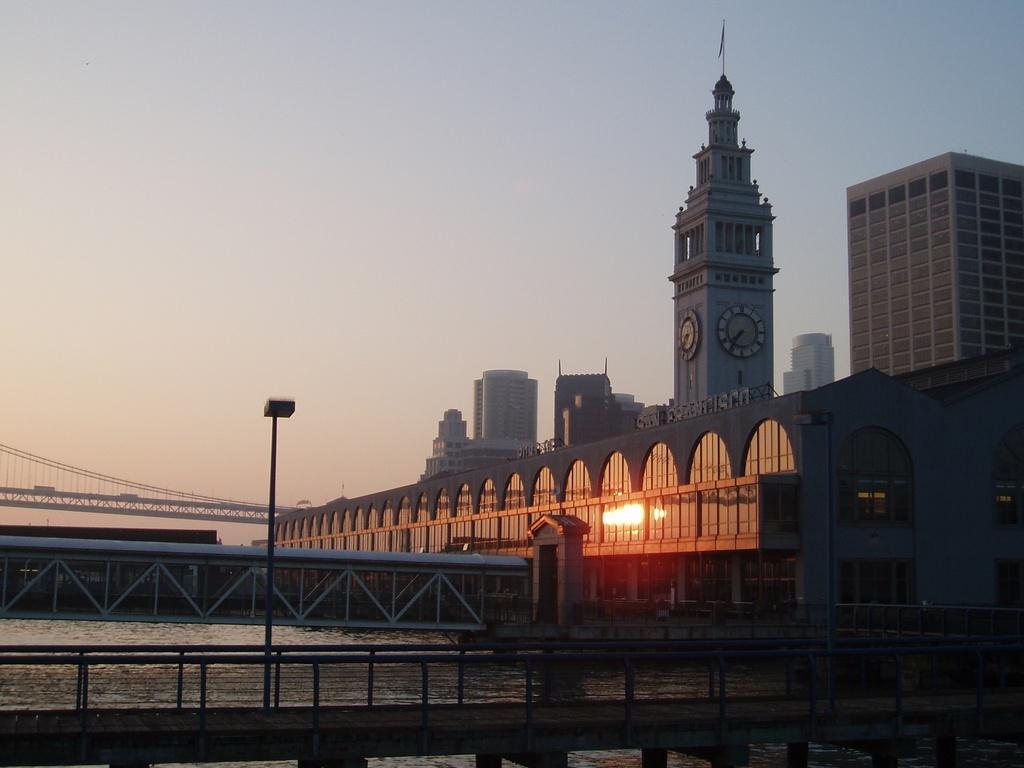Could you give a brief overview of what you see in this image? This looks like a clock tower with the wall clocks attached to it. I can see the buildings with the glass doors. I think these are the bridges. I think this is a street light. This is the sky. 